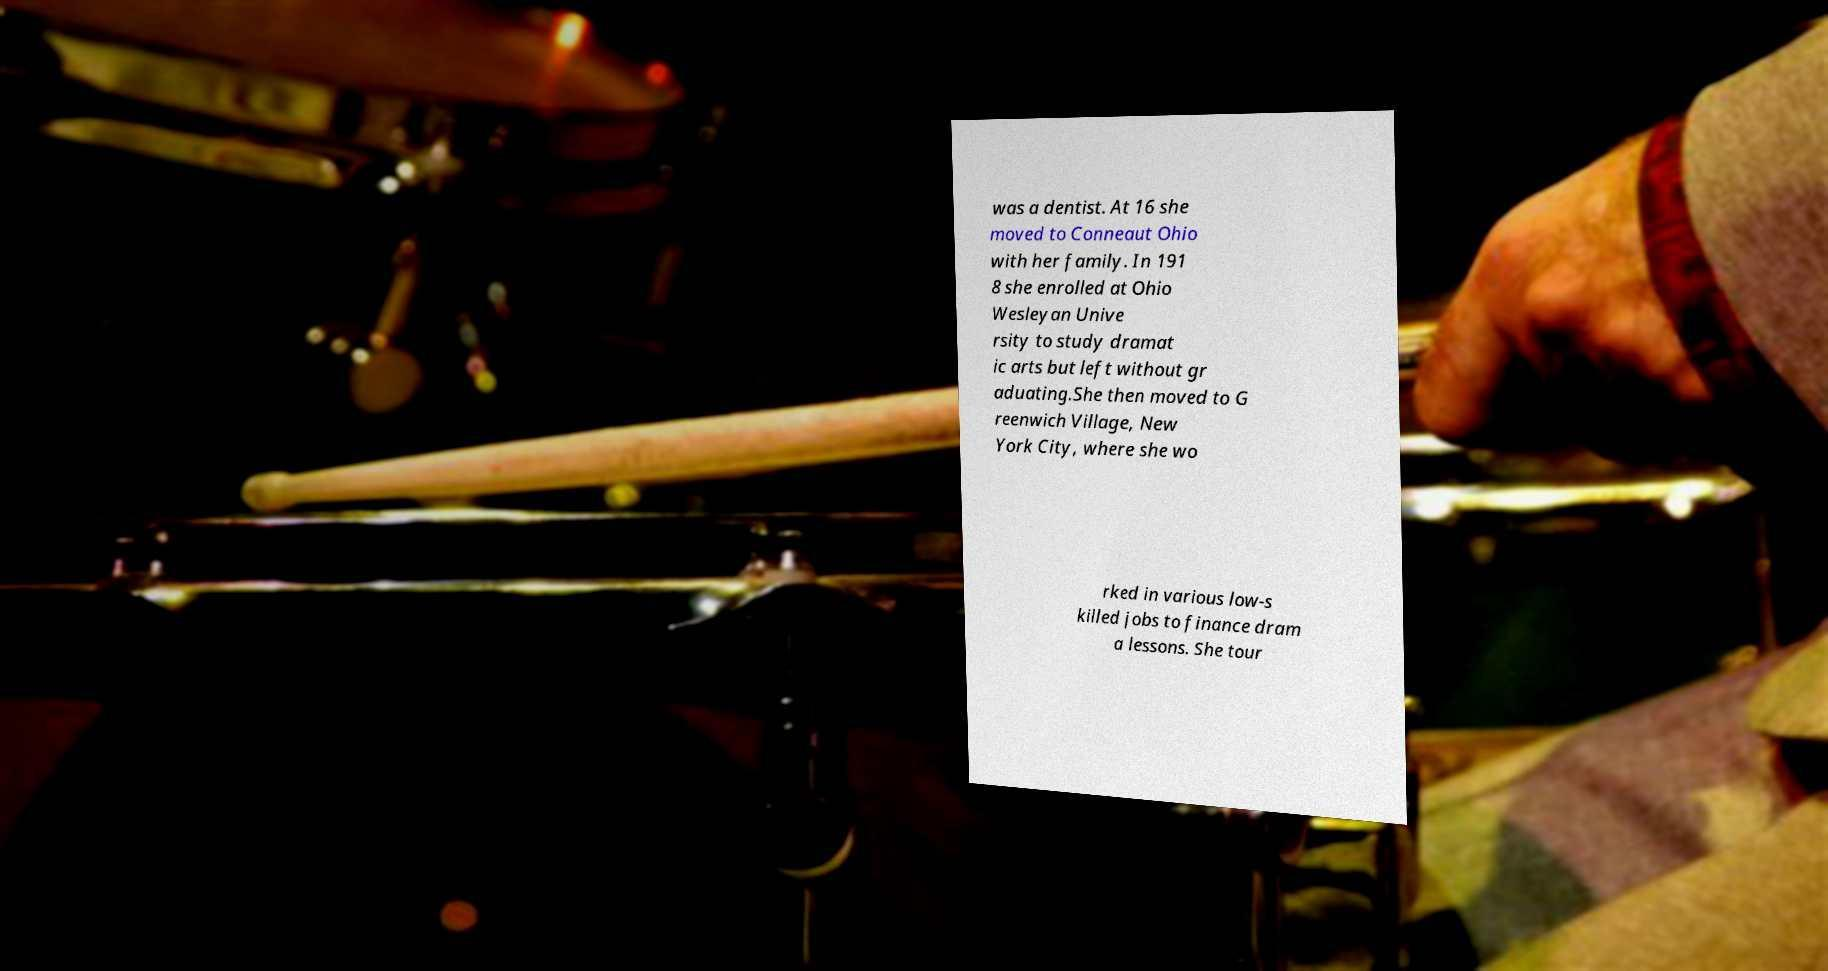For documentation purposes, I need the text within this image transcribed. Could you provide that? was a dentist. At 16 she moved to Conneaut Ohio with her family. In 191 8 she enrolled at Ohio Wesleyan Unive rsity to study dramat ic arts but left without gr aduating.She then moved to G reenwich Village, New York City, where she wo rked in various low-s killed jobs to finance dram a lessons. She tour 